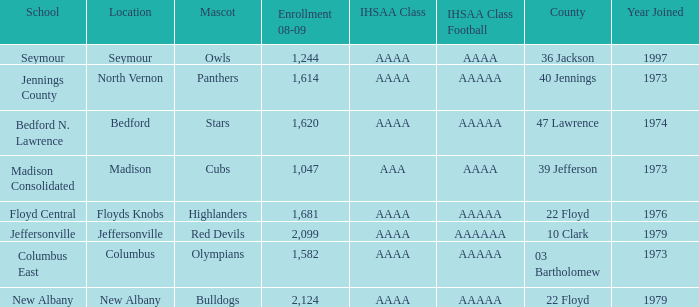What school is in 36 Jackson? Seymour. 